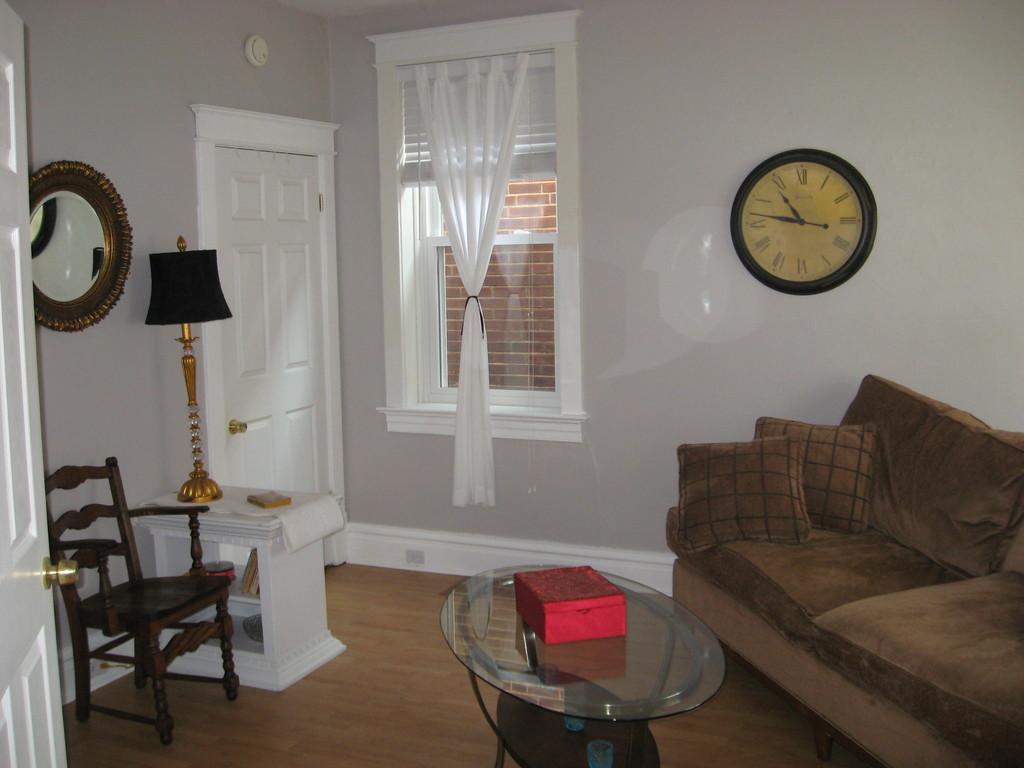How would you summarize this image in a sentence or two? In this picture there is a white color door at the left side a desk and a lamp, there is a window at the center of the image with curtains and there is a sofa which is brown in color at the right side of the image, a clock which is placed on the wall and a table at the center of the image, a chair which is placed near the desk at the left side of the image. 